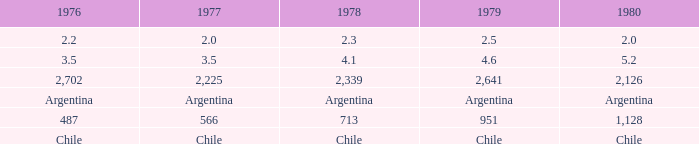What is 1977 when 1978 is 4.1? 3.5. 